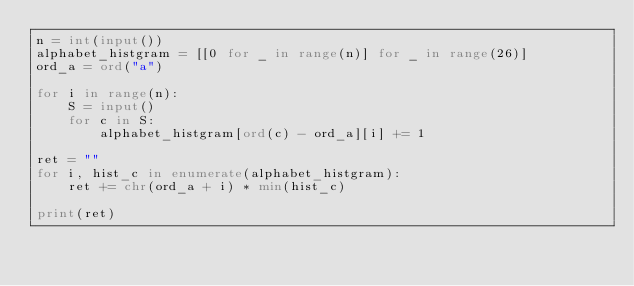<code> <loc_0><loc_0><loc_500><loc_500><_Python_>n = int(input())
alphabet_histgram = [[0 for _ in range(n)] for _ in range(26)]
ord_a = ord("a")

for i in range(n):
    S = input()
    for c in S:
        alphabet_histgram[ord(c) - ord_a][i] += 1

ret = ""
for i, hist_c in enumerate(alphabet_histgram):
    ret += chr(ord_a + i) * min(hist_c)

print(ret)
</code> 